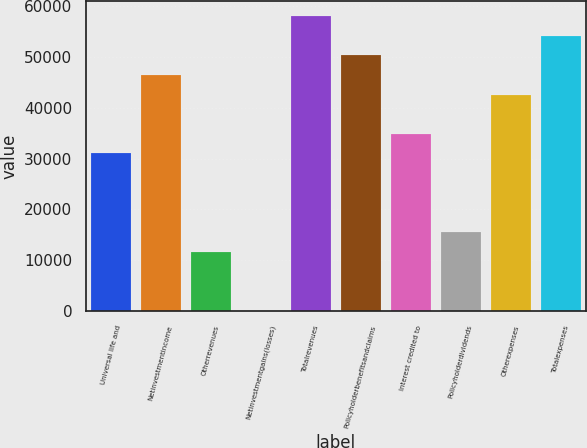<chart> <loc_0><loc_0><loc_500><loc_500><bar_chart><fcel>Universal life and<fcel>Netinvestmentincome<fcel>Otherrevenues<fcel>Netinvestmentgains(losses)<fcel>Totalrevenues<fcel>Policyholderbenefitsandclaims<fcel>Interest credited to<fcel>Policyholderdividends<fcel>Otherexpenses<fcel>Totalexpenses<nl><fcel>30995.8<fcel>46406.2<fcel>11732.8<fcel>175<fcel>57964<fcel>50258.8<fcel>34848.4<fcel>15585.4<fcel>42553.6<fcel>54111.4<nl></chart> 